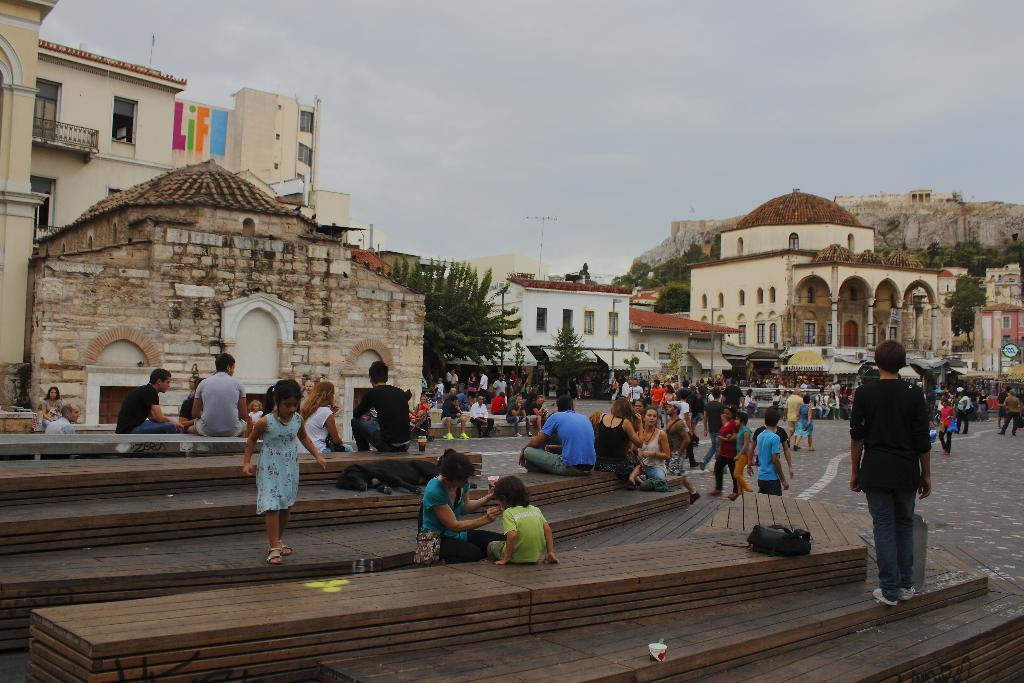What are the people in the image doing? There are people sitting and walking in the image. What structures can be seen in the image? There are buildings in the image. What type of vegetation is present in the image? There are trees in the image. What is visible at the top of the image? The sky is visible at the top of the image. What is the condition of the sky in the image? The sky is cloudy in the image. Can you tell me how many swings are visible in the image? There are no swings present in the image. What color is the hair of the scarecrow in the image? There is no scarecrow present in the image. 